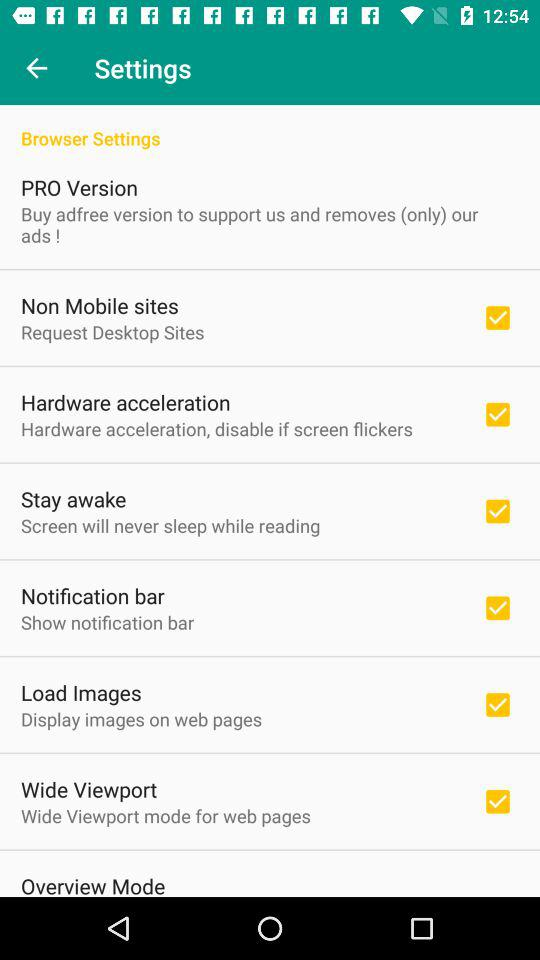What is the status of the "Non Mobile sites"? The status is on. 